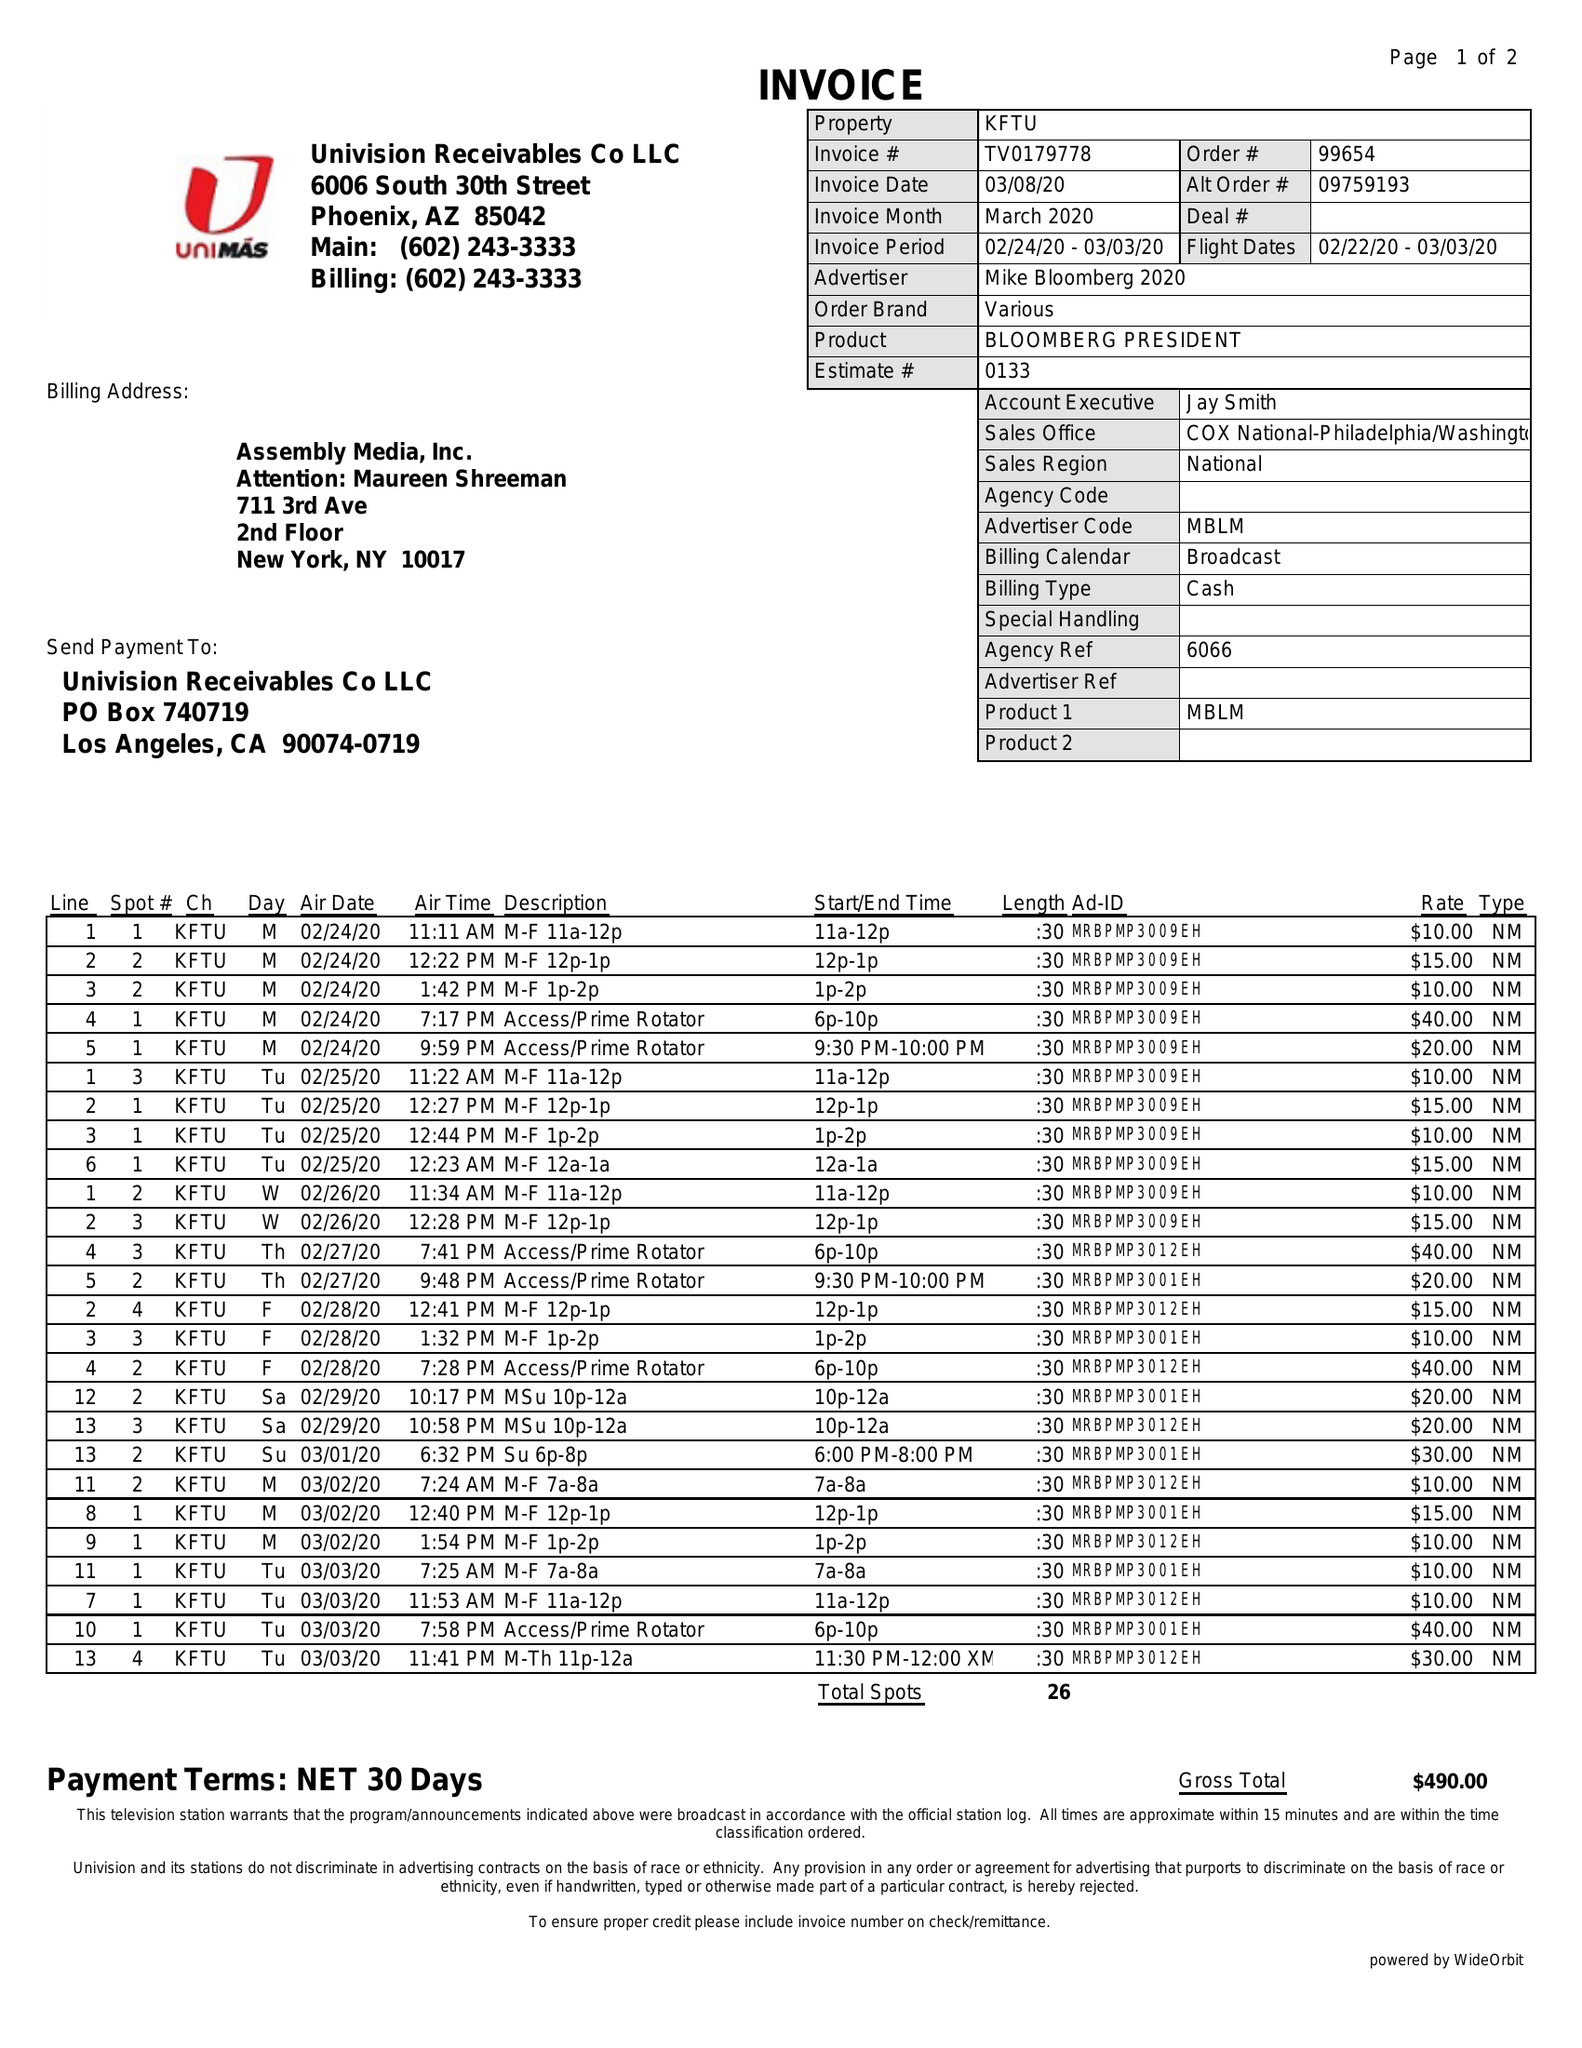What is the value for the contract_num?
Answer the question using a single word or phrase. TV0179778 